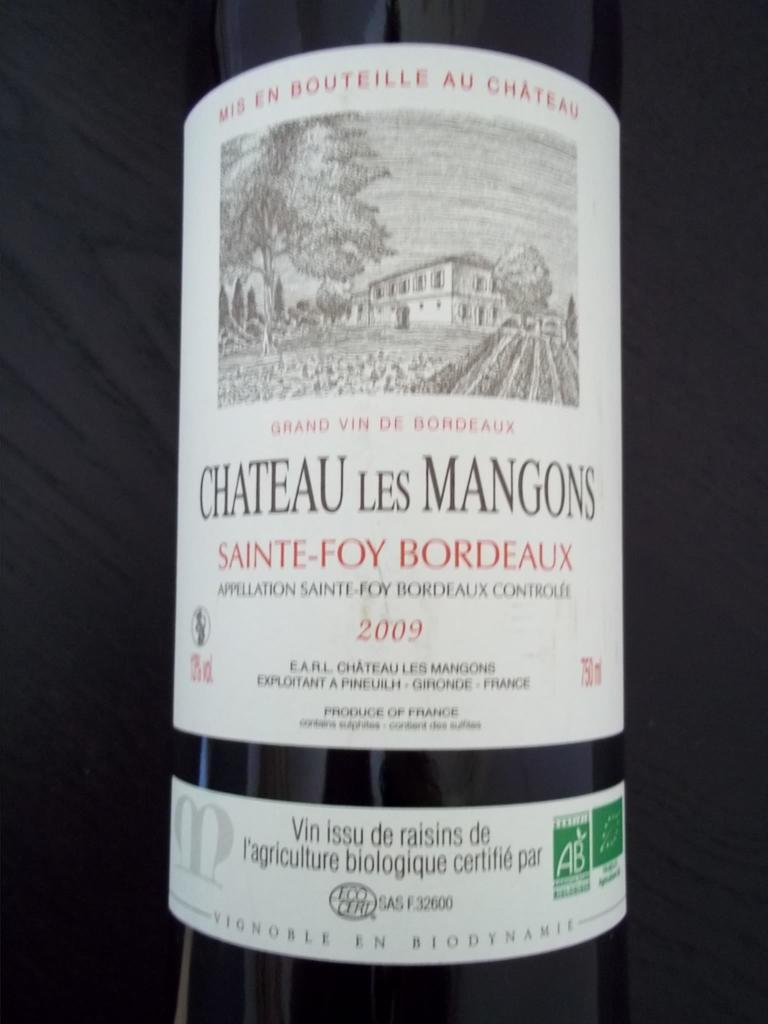<image>
Present a compact description of the photo's key features. Bottle with a white label that says "Chateau Les Mangons" on it. 